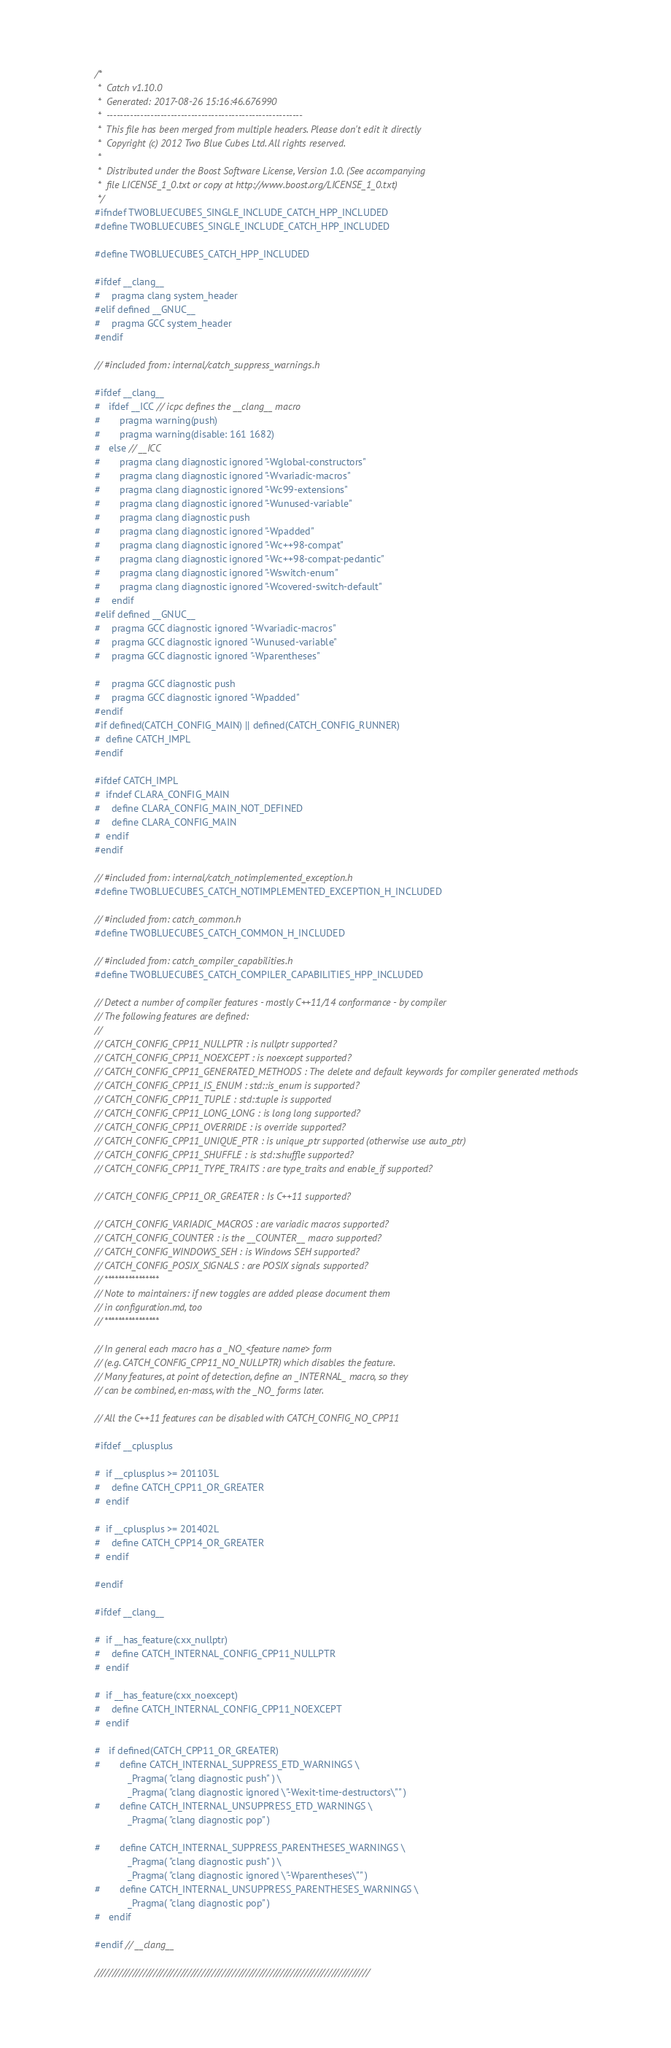<code> <loc_0><loc_0><loc_500><loc_500><_C++_>/*
 *  Catch v1.10.0
 *  Generated: 2017-08-26 15:16:46.676990
 *  ----------------------------------------------------------
 *  This file has been merged from multiple headers. Please don't edit it directly
 *  Copyright (c) 2012 Two Blue Cubes Ltd. All rights reserved.
 *
 *  Distributed under the Boost Software License, Version 1.0. (See accompanying
 *  file LICENSE_1_0.txt or copy at http://www.boost.org/LICENSE_1_0.txt)
 */
#ifndef TWOBLUECUBES_SINGLE_INCLUDE_CATCH_HPP_INCLUDED
#define TWOBLUECUBES_SINGLE_INCLUDE_CATCH_HPP_INCLUDED

#define TWOBLUECUBES_CATCH_HPP_INCLUDED

#ifdef __clang__
#    pragma clang system_header
#elif defined __GNUC__
#    pragma GCC system_header
#endif

// #included from: internal/catch_suppress_warnings.h

#ifdef __clang__
#   ifdef __ICC // icpc defines the __clang__ macro
#       pragma warning(push)
#       pragma warning(disable: 161 1682)
#   else // __ICC
#       pragma clang diagnostic ignored "-Wglobal-constructors"
#       pragma clang diagnostic ignored "-Wvariadic-macros"
#       pragma clang diagnostic ignored "-Wc99-extensions"
#       pragma clang diagnostic ignored "-Wunused-variable"
#       pragma clang diagnostic push
#       pragma clang diagnostic ignored "-Wpadded"
#       pragma clang diagnostic ignored "-Wc++98-compat"
#       pragma clang diagnostic ignored "-Wc++98-compat-pedantic"
#       pragma clang diagnostic ignored "-Wswitch-enum"
#       pragma clang diagnostic ignored "-Wcovered-switch-default"
#    endif
#elif defined __GNUC__
#    pragma GCC diagnostic ignored "-Wvariadic-macros"
#    pragma GCC diagnostic ignored "-Wunused-variable"
#    pragma GCC diagnostic ignored "-Wparentheses"

#    pragma GCC diagnostic push
#    pragma GCC diagnostic ignored "-Wpadded"
#endif
#if defined(CATCH_CONFIG_MAIN) || defined(CATCH_CONFIG_RUNNER)
#  define CATCH_IMPL
#endif

#ifdef CATCH_IMPL
#  ifndef CLARA_CONFIG_MAIN
#    define CLARA_CONFIG_MAIN_NOT_DEFINED
#    define CLARA_CONFIG_MAIN
#  endif
#endif

// #included from: internal/catch_notimplemented_exception.h
#define TWOBLUECUBES_CATCH_NOTIMPLEMENTED_EXCEPTION_H_INCLUDED

// #included from: catch_common.h
#define TWOBLUECUBES_CATCH_COMMON_H_INCLUDED

// #included from: catch_compiler_capabilities.h
#define TWOBLUECUBES_CATCH_COMPILER_CAPABILITIES_HPP_INCLUDED

// Detect a number of compiler features - mostly C++11/14 conformance - by compiler
// The following features are defined:
//
// CATCH_CONFIG_CPP11_NULLPTR : is nullptr supported?
// CATCH_CONFIG_CPP11_NOEXCEPT : is noexcept supported?
// CATCH_CONFIG_CPP11_GENERATED_METHODS : The delete and default keywords for compiler generated methods
// CATCH_CONFIG_CPP11_IS_ENUM : std::is_enum is supported?
// CATCH_CONFIG_CPP11_TUPLE : std::tuple is supported
// CATCH_CONFIG_CPP11_LONG_LONG : is long long supported?
// CATCH_CONFIG_CPP11_OVERRIDE : is override supported?
// CATCH_CONFIG_CPP11_UNIQUE_PTR : is unique_ptr supported (otherwise use auto_ptr)
// CATCH_CONFIG_CPP11_SHUFFLE : is std::shuffle supported?
// CATCH_CONFIG_CPP11_TYPE_TRAITS : are type_traits and enable_if supported?

// CATCH_CONFIG_CPP11_OR_GREATER : Is C++11 supported?

// CATCH_CONFIG_VARIADIC_MACROS : are variadic macros supported?
// CATCH_CONFIG_COUNTER : is the __COUNTER__ macro supported?
// CATCH_CONFIG_WINDOWS_SEH : is Windows SEH supported?
// CATCH_CONFIG_POSIX_SIGNALS : are POSIX signals supported?
// ****************
// Note to maintainers: if new toggles are added please document them
// in configuration.md, too
// ****************

// In general each macro has a _NO_<feature name> form
// (e.g. CATCH_CONFIG_CPP11_NO_NULLPTR) which disables the feature.
// Many features, at point of detection, define an _INTERNAL_ macro, so they
// can be combined, en-mass, with the _NO_ forms later.

// All the C++11 features can be disabled with CATCH_CONFIG_NO_CPP11

#ifdef __cplusplus

#  if __cplusplus >= 201103L
#    define CATCH_CPP11_OR_GREATER
#  endif

#  if __cplusplus >= 201402L
#    define CATCH_CPP14_OR_GREATER
#  endif

#endif

#ifdef __clang__

#  if __has_feature(cxx_nullptr)
#    define CATCH_INTERNAL_CONFIG_CPP11_NULLPTR
#  endif

#  if __has_feature(cxx_noexcept)
#    define CATCH_INTERNAL_CONFIG_CPP11_NOEXCEPT
#  endif

#   if defined(CATCH_CPP11_OR_GREATER)
#       define CATCH_INTERNAL_SUPPRESS_ETD_WARNINGS \
            _Pragma( "clang diagnostic push" ) \
            _Pragma( "clang diagnostic ignored \"-Wexit-time-destructors\"" )
#       define CATCH_INTERNAL_UNSUPPRESS_ETD_WARNINGS \
            _Pragma( "clang diagnostic pop" )

#       define CATCH_INTERNAL_SUPPRESS_PARENTHESES_WARNINGS \
            _Pragma( "clang diagnostic push" ) \
            _Pragma( "clang diagnostic ignored \"-Wparentheses\"" )
#       define CATCH_INTERNAL_UNSUPPRESS_PARENTHESES_WARNINGS \
            _Pragma( "clang diagnostic pop" )
#   endif

#endif // __clang__

////////////////////////////////////////////////////////////////////////////////</code> 